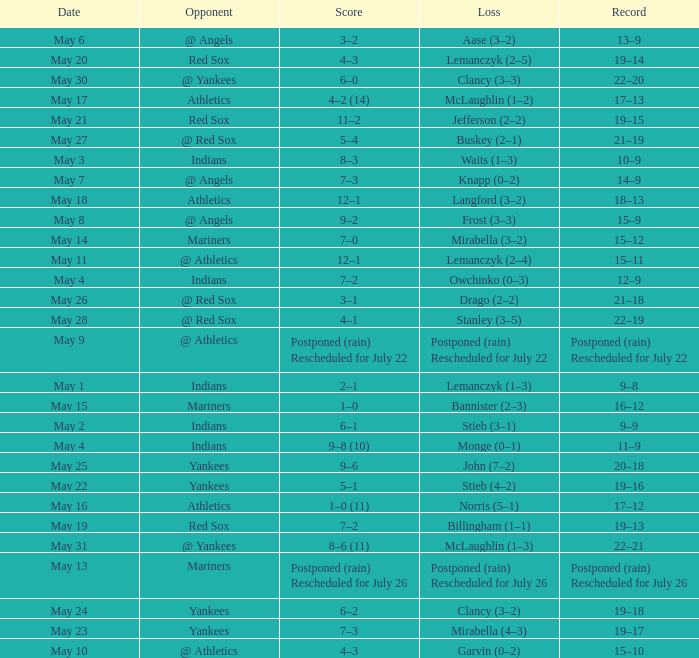Name the loss on may 22 Stieb (4–2). 